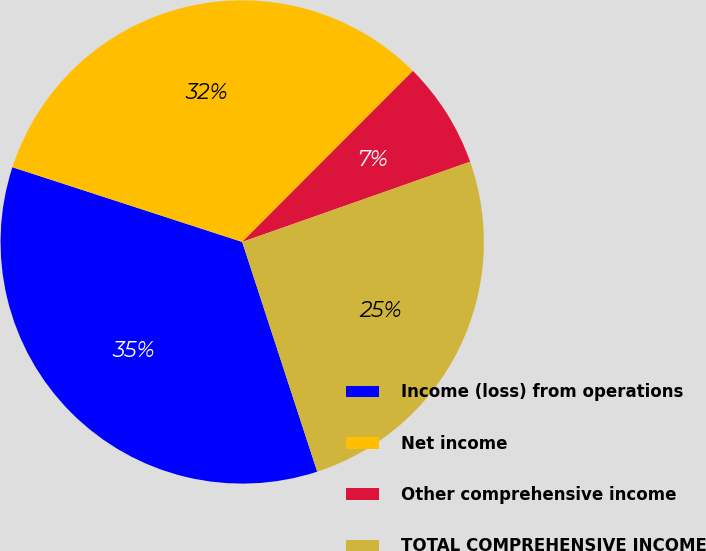Convert chart to OTSL. <chart><loc_0><loc_0><loc_500><loc_500><pie_chart><fcel>Income (loss) from operations<fcel>Net income<fcel>Other comprehensive income<fcel>TOTAL COMPREHENSIVE INCOME<nl><fcel>35.03%<fcel>32.48%<fcel>7.13%<fcel>25.36%<nl></chart> 